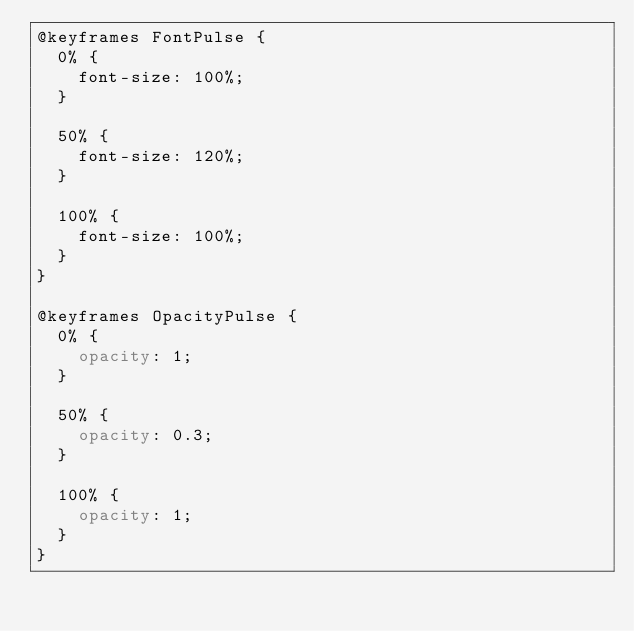Convert code to text. <code><loc_0><loc_0><loc_500><loc_500><_CSS_>@keyframes FontPulse {
  0% {
    font-size: 100%;
  }

  50% {
    font-size: 120%;
  }

  100% {
    font-size: 100%;
  }
}

@keyframes OpacityPulse {
  0% {
    opacity: 1;
  }

  50% {
    opacity: 0.3;
  }

  100% {
    opacity: 1;
  }
}
</code> 